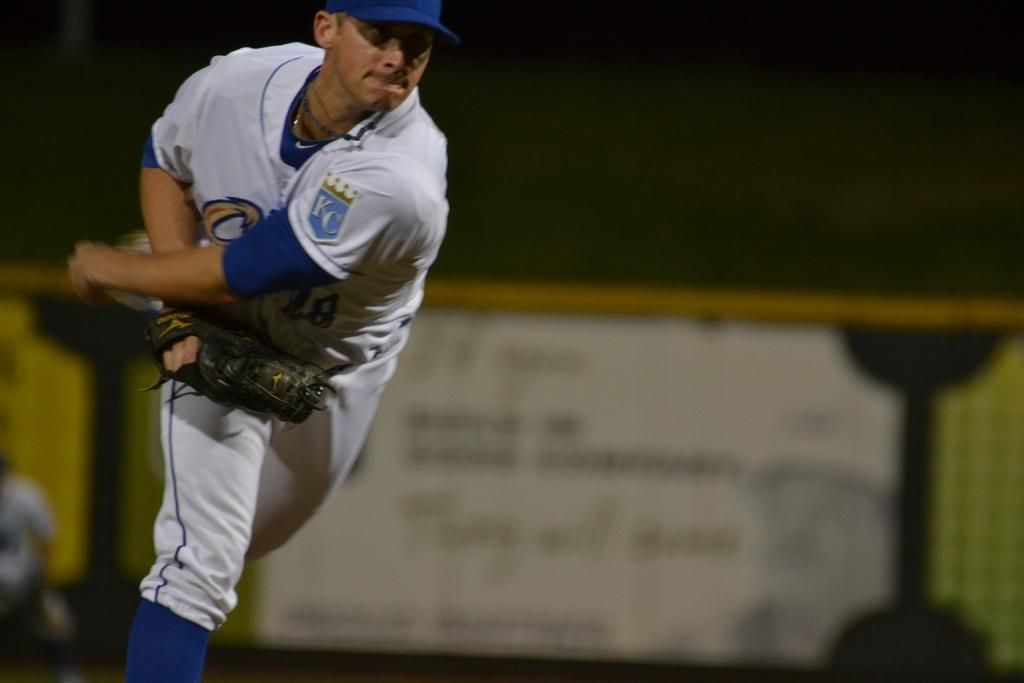Provide a one-sentence caption for the provided image. An athlete mid throw with a KC emblem on his left shoulder. 